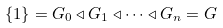Convert formula to latex. <formula><loc_0><loc_0><loc_500><loc_500>\{ 1 \} = G _ { 0 } \triangleleft G _ { 1 } \triangleleft \dots \triangleleft G _ { n } = G</formula> 